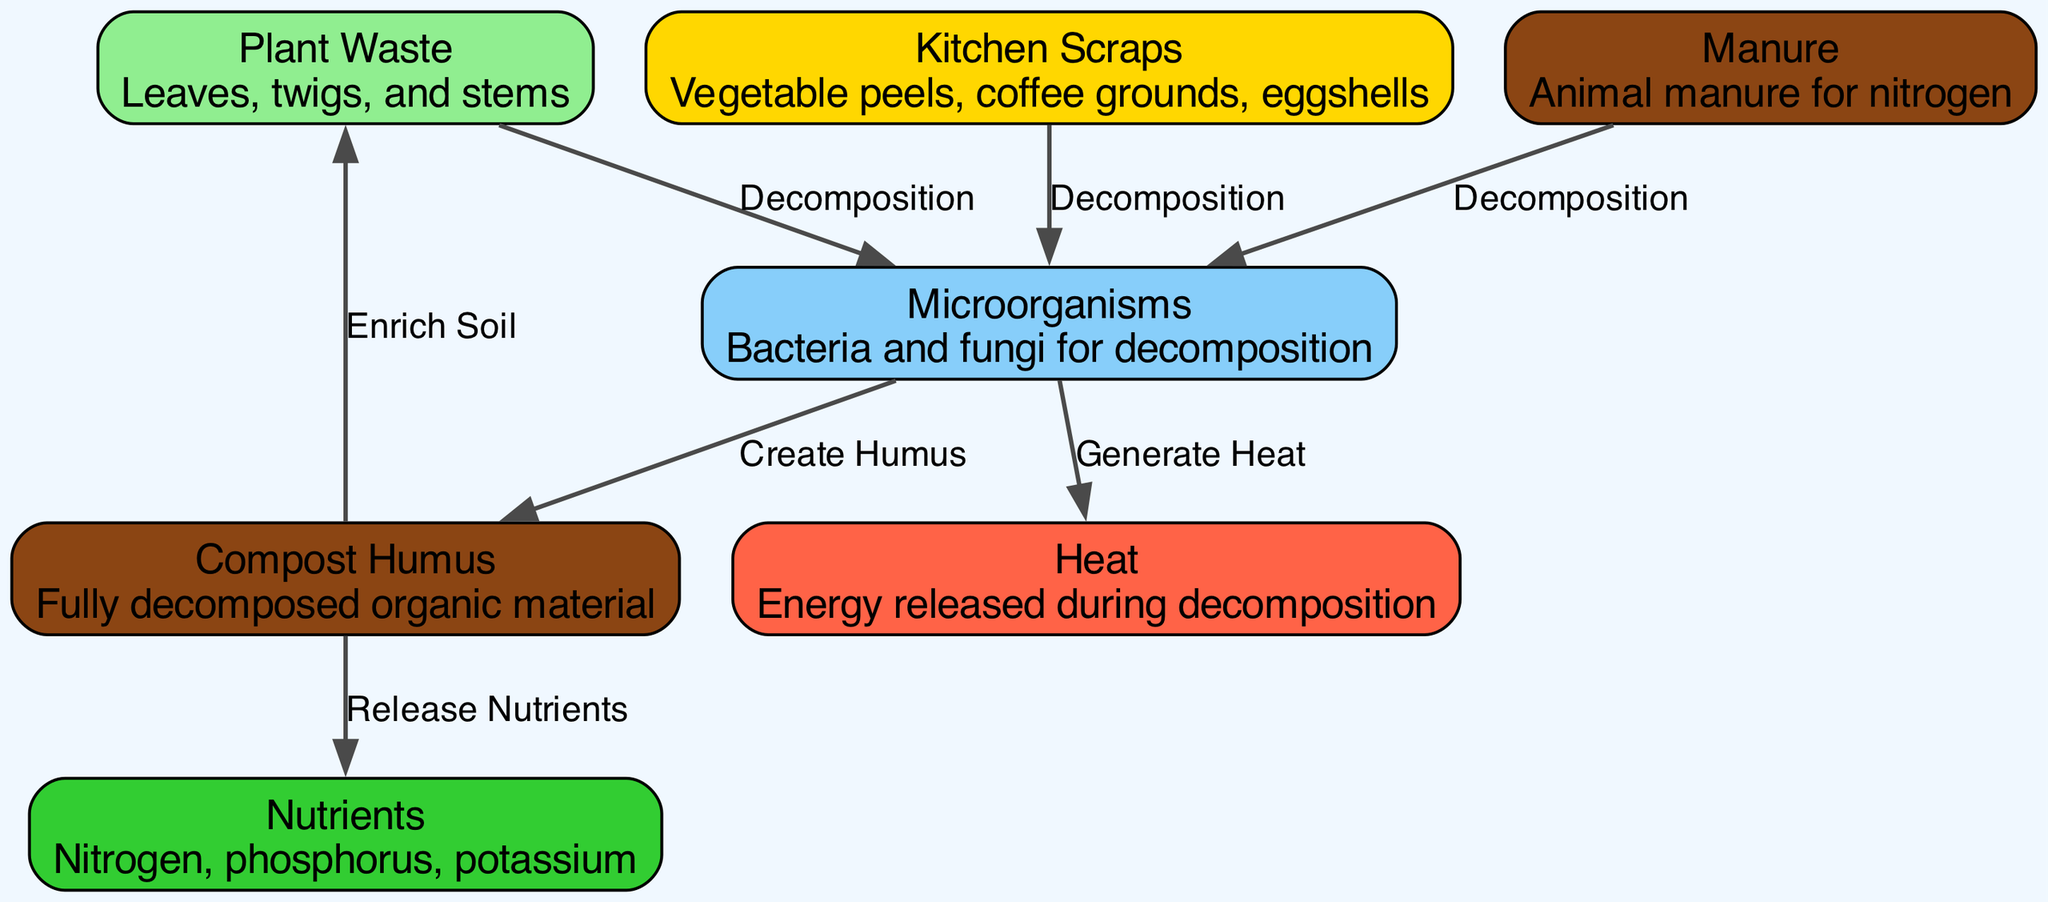What are the main components of a compost pile? The diagram reveals several main components of a compost pile, including Plant Waste, Kitchen Scraps, Manure, Microorganisms, Compost Humus, Nutrients, and Heat. These elements are crucial in illustrating the nutrient cycling process within the composting system.
Answer: Plant Waste, Kitchen Scraps, Manure, Microorganisms, Compost Humus, Nutrients, Heat How many edges are present in the diagram? By reviewing the connections (or edges) that link the various nodes, we can count a total of 6 edges. Each edge corresponds to a specific process or relationship between the components involved in the nutrient cycle.
Answer: 6 What process connects Manure to Microorganisms? The diagram shows that Manure is connected to Microorganisms through the process of Decomposition. This signifies the role of manure in promoting microbial activity as part of organic breakdown.
Answer: Decomposition What does Microorganisms generate during the decomposition process? The diagram indicates that Microorganisms generate Heat as a byproduct of their activity during the decomposition of organic materials. This heat is essential in the composting process, influencing the breakdown of organic waste.
Answer: Heat What happens to Compost Humus in relation to Nutrients? The connection from Compost Humus to Nutrients indicates that Compost Humus releases Nutrients. This release is important for enriching soil, making nutrients available for plants.
Answer: Release Nutrients How does Compost Humus benefit Plant Waste? The diagram shows that Compost Humus enriches Soil, which indirectly benefits Plant Waste by improving soil quality and nutrient availability for plant growth and sustainability.
Answer: Enrich Soil What is the role of Microorganisms in the compost process? The diagram illustrates that Microorganisms are key players in the composting process, engaging in both decomposition of organic materials and creation of humus, which ultimately contributes to nutrient cycling.
Answer: Decomposition and Create Humus 